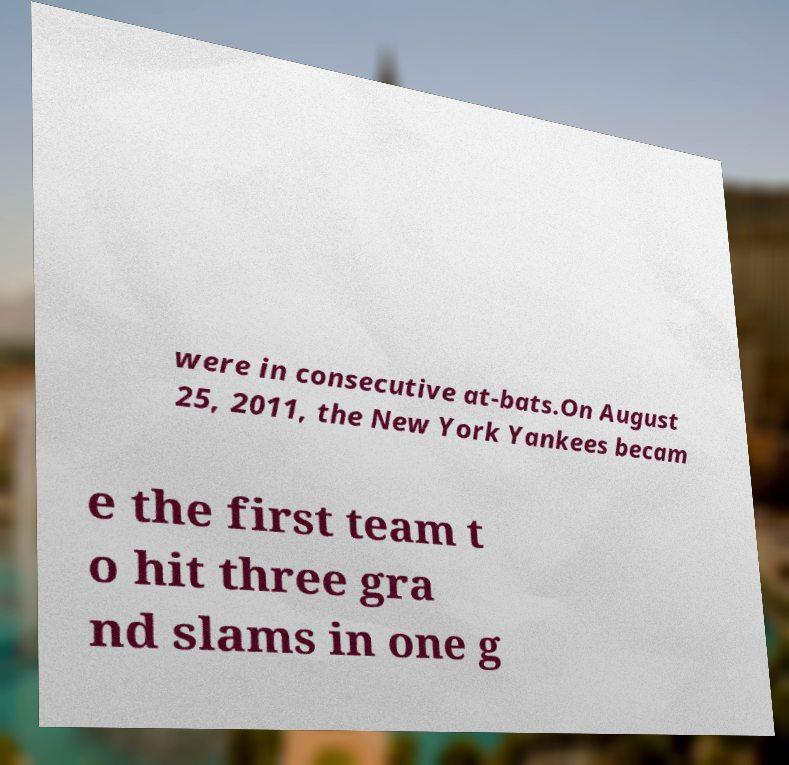What messages or text are displayed in this image? I need them in a readable, typed format. were in consecutive at-bats.On August 25, 2011, the New York Yankees becam e the first team t o hit three gra nd slams in one g 